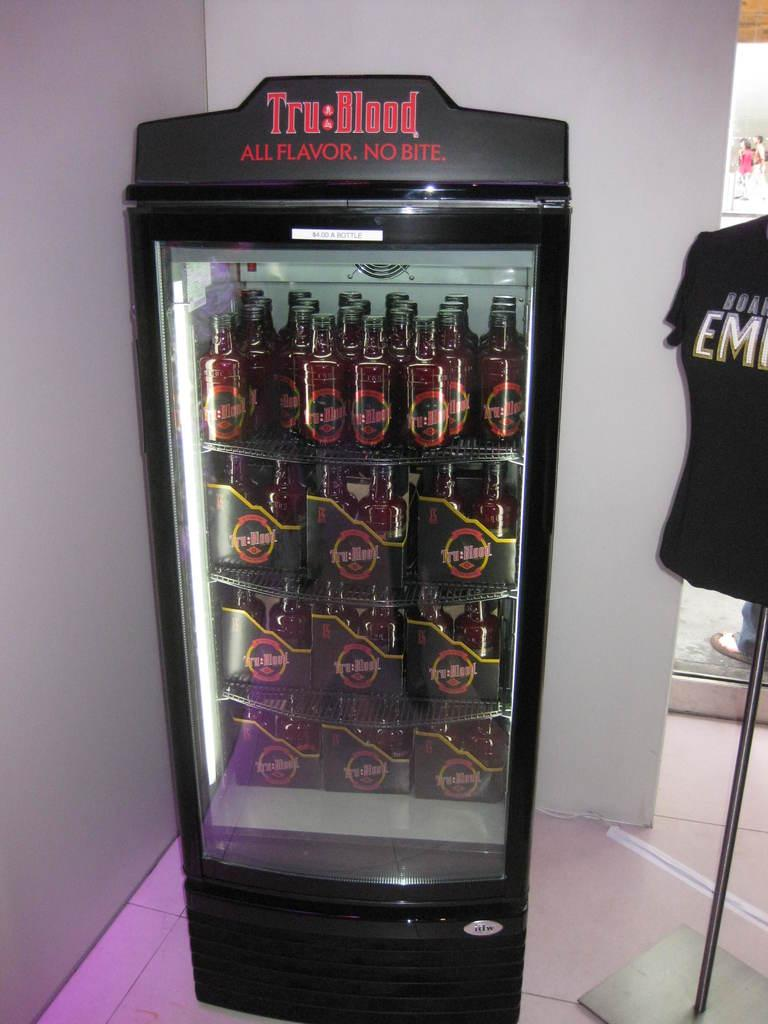<image>
Share a concise interpretation of the image provided. A black cooler contains bottles of Tru Blood. 